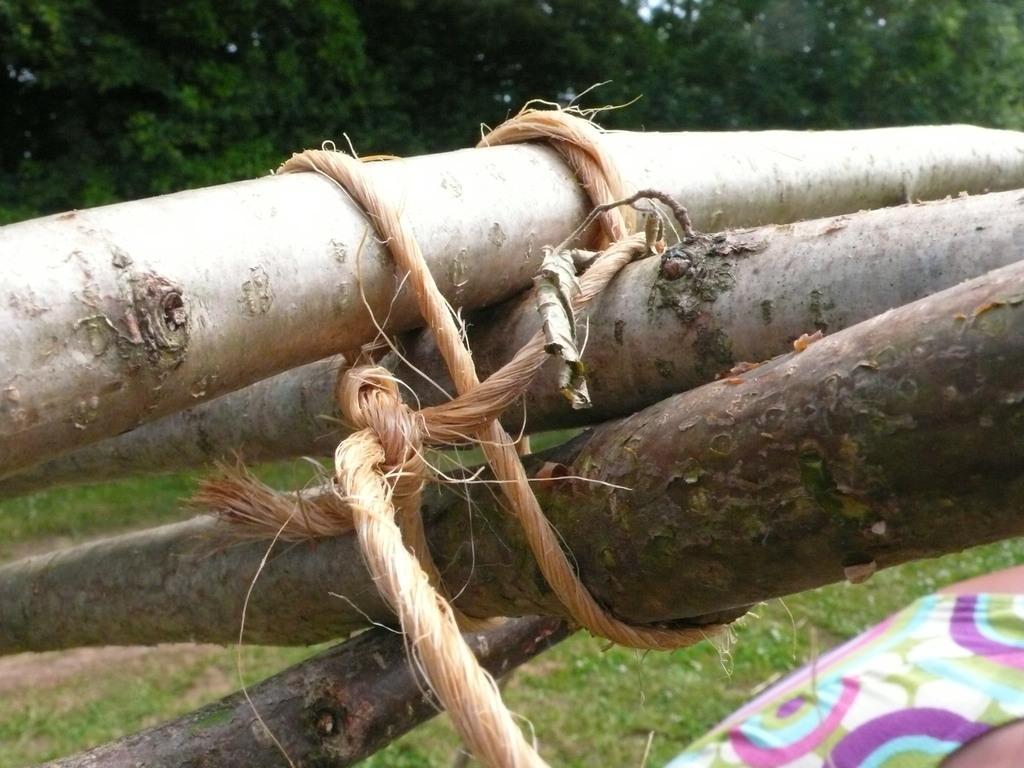In one or two sentences, can you explain what this image depicts? In this image we can see wooden sticks are tied with coir rope. Here we can see a person, grass and the trees in the background. 